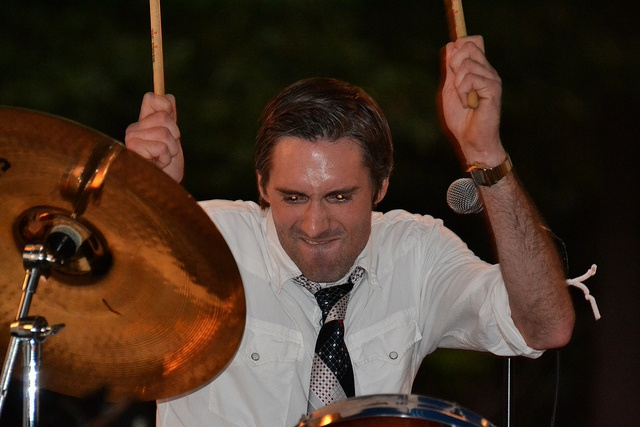Describe the objects in this image and their specific colors. I can see people in black, darkgray, brown, and maroon tones and tie in black, gray, darkgray, and maroon tones in this image. 